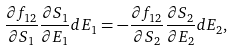Convert formula to latex. <formula><loc_0><loc_0><loc_500><loc_500>\frac { \partial f _ { 1 2 } } { \partial S _ { 1 } } \frac { \partial S _ { 1 } } { \partial E _ { 1 } } d E _ { 1 } = - \frac { \partial f _ { 1 2 } } { \partial S _ { 2 } } \frac { \partial S _ { 2 } } { \partial E _ { 2 } } d E _ { 2 } ,</formula> 